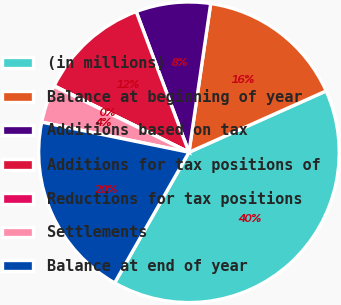Convert chart. <chart><loc_0><loc_0><loc_500><loc_500><pie_chart><fcel>(in millions)<fcel>Balance at beginning of year<fcel>Additions based on tax<fcel>Additions for tax positions of<fcel>Reductions for tax positions<fcel>Settlements<fcel>Balance at end of year<nl><fcel>39.93%<fcel>16.0%<fcel>8.02%<fcel>12.01%<fcel>0.04%<fcel>4.03%<fcel>19.98%<nl></chart> 